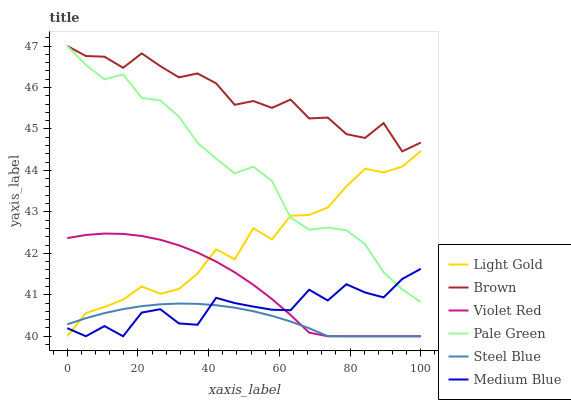Does Violet Red have the minimum area under the curve?
Answer yes or no. No. Does Violet Red have the maximum area under the curve?
Answer yes or no. No. Is Violet Red the smoothest?
Answer yes or no. No. Is Violet Red the roughest?
Answer yes or no. No. Does Pale Green have the lowest value?
Answer yes or no. No. Does Violet Red have the highest value?
Answer yes or no. No. Is Steel Blue less than Pale Green?
Answer yes or no. Yes. Is Brown greater than Violet Red?
Answer yes or no. Yes. Does Steel Blue intersect Pale Green?
Answer yes or no. No. 